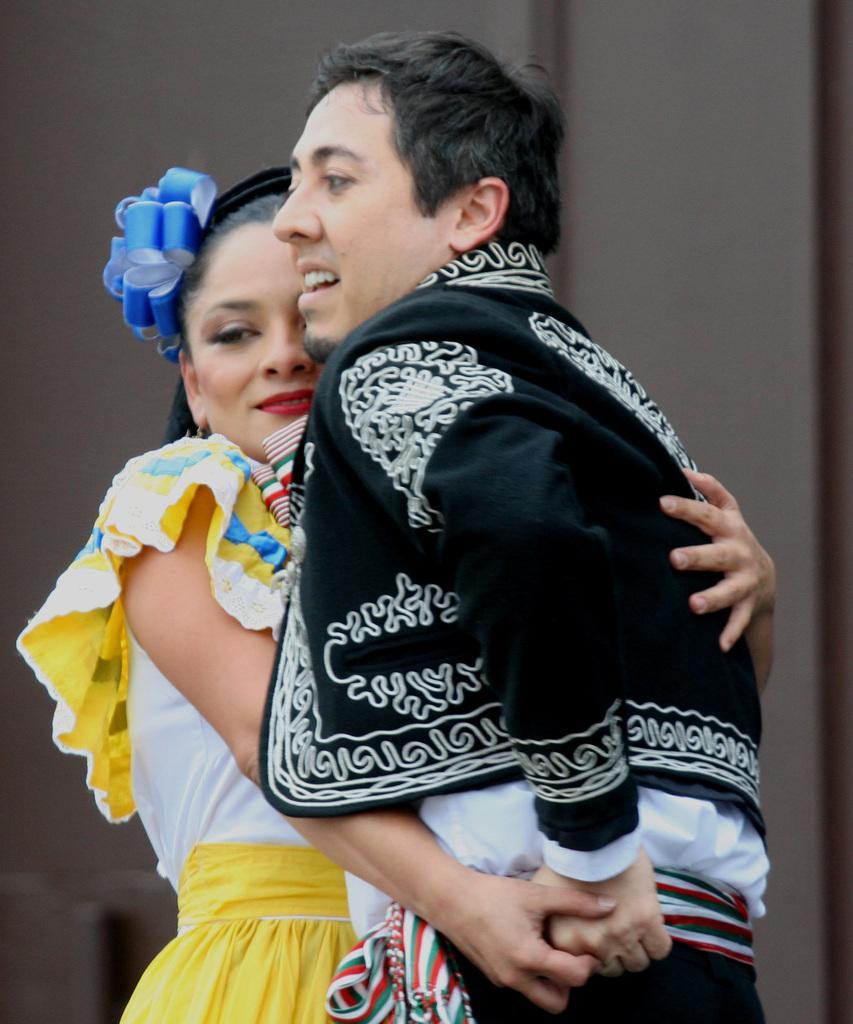Describe this image in one or two sentences. This is a zoomed in picture. In the foreground we can see the two persons standing and hugging each other. In the background we can see the wall. 